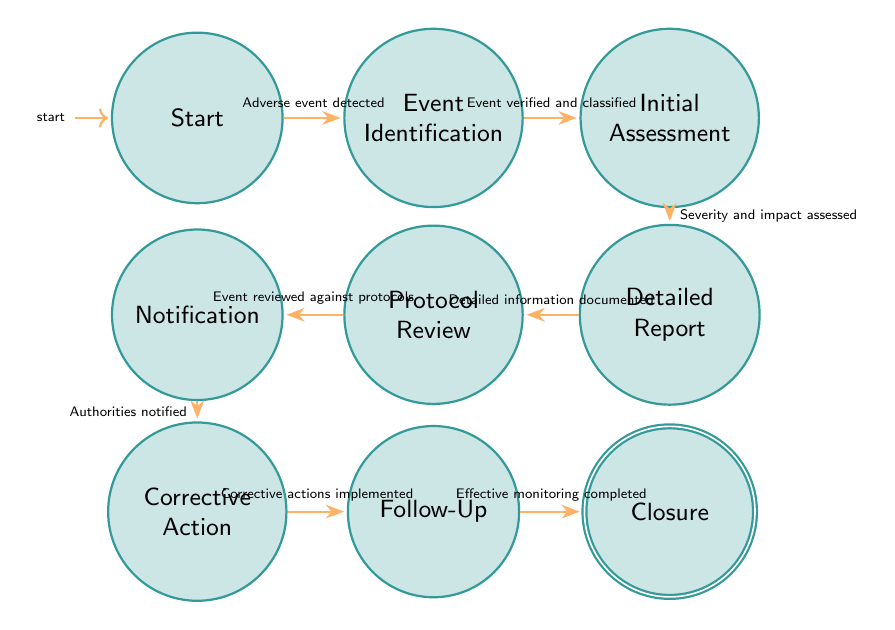What is the initial state in the diagram? The initial state in the diagram is the starting point where the adverse event detection occurs. It is labeled as "Start".
Answer: Start How many states are in the diagram? By counting the nodes representing distinct statuses from "Start" to "Closure," there are a total of nine states in the diagram.
Answer: Nine What is the condition to transition from "Detailed Report" to "Protocol Review"? The condition for this transition indicates that detailed information about the event must be documented before moving to the next state. This condition is stated as "Detailed information documented."
Answer: Detailed information documented Which state follows "Initial Assessment"? After the state of "Initial Assessment" is completed successfully, the next step involves assessing the event further, which leads to the state labeled "Detailed Report."
Answer: Detailed Report What action is associated with transitioning from "Notification" to "Corrective Action"? The transition from "Notification" to "Corrective Action" involves notifying relevant authorities and then implementing the necessary corrective actions based on their guidance. It indicates that corrective actions should be implemented.
Answer: Implement corrective actions What is required before notifying authorities in "Notification"? Before proceeding to notify the relevant authorities, the event must first be thoroughly reviewed against the existing protocols. Thus, it must confirm that the event has been reviewed.
Answer: Event reviewed against protocols What happens after "Follow-Up"? Once follow-up actions are taken and effective monitoring is completed satisfactorily, the process concludes with the state called "Closure."
Answer: Closure What is the purpose of the "Protocol Review" state? The "Protocol Review" state is intended for comparing the details of the adverse event against existing protocols and guidelines to ensure proper adherence. It functions primarily as a verification step.
Answer: Review against protocols What indicates movement from "Corrective Action" to "Follow-Up"? After implementing the corrective actions, the system requires conducting a follow-up to monitor the effectiveness of those actions. This is indicated by having effective corrective actions implemented to proceed.
Answer: Corrective actions implemented 